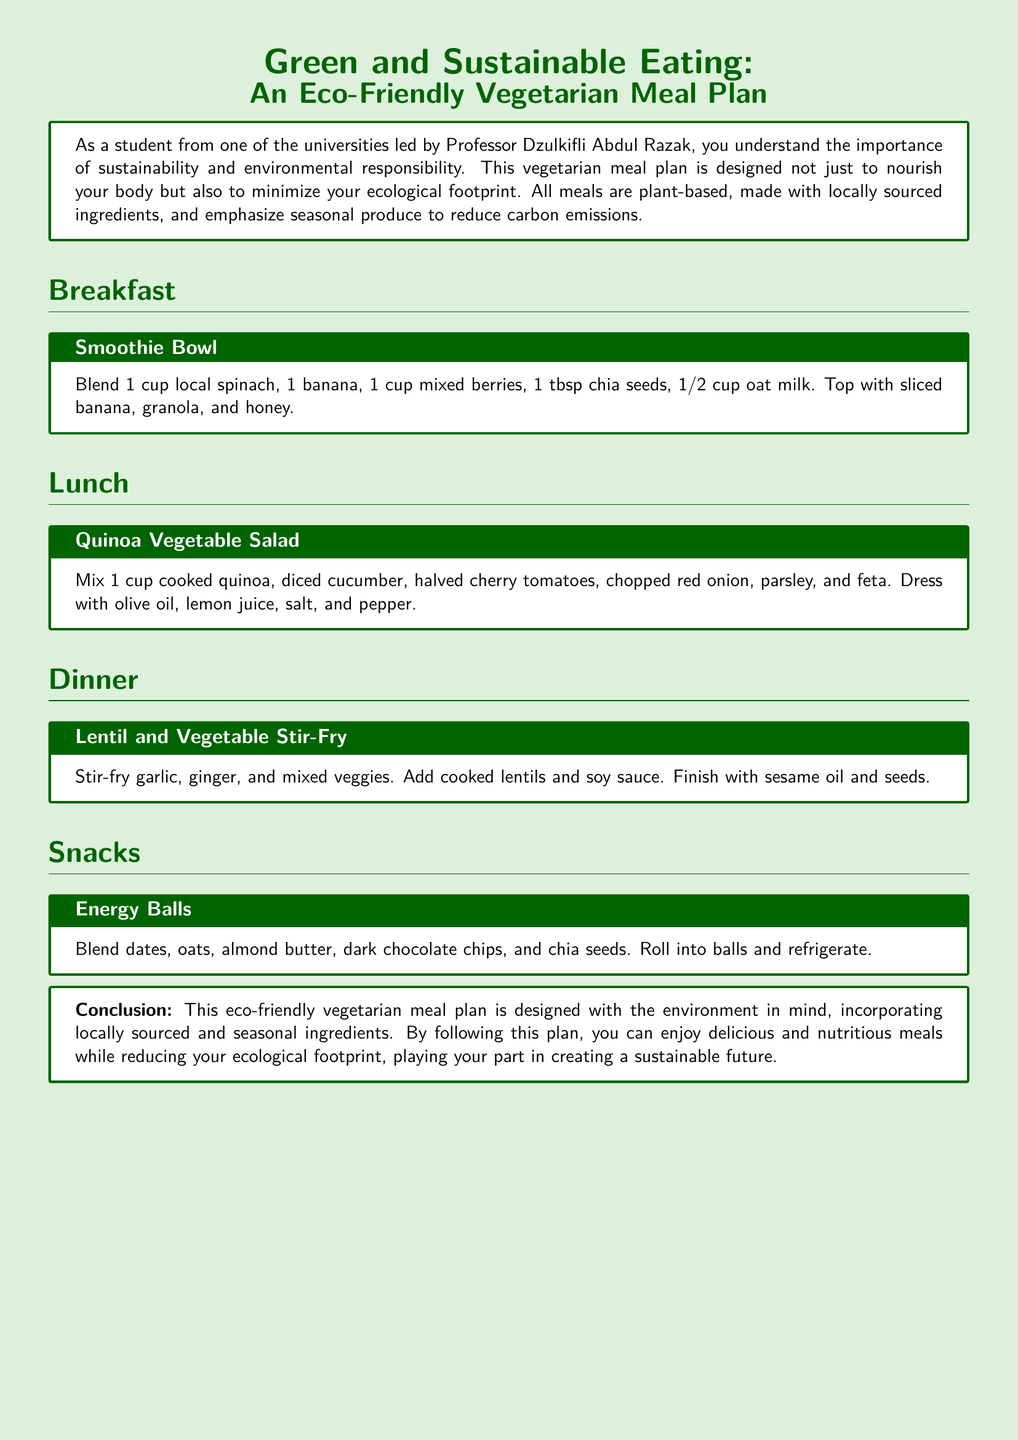What is the title of the meal plan? The title presents the main focus of the document, which emphasizes green and sustainable eating practices.
Answer: Green and Sustainable Eating: An Eco-Friendly Vegetarian Meal Plan Who is the target audience for the meal plan? The introduction specifies the intended audience who are environmentally conscious students connected to a specific university.
Answer: Environmentally conscious student How many sections are there in the meal plan? The document includes several distinct sections focusing on different meals throughout the day.
Answer: Four What key ingredient is in the smoothie bowl? The smoothie bowl recipe lists specific ingredients that contribute to its flavor and nutritional value.
Answer: Spinach What is used to dress the quinoa vegetable salad? The salad preparation mentions specific items used to enhance taste and freshness in the recipe.
Answer: Olive oil and lemon juice What type of meal is the energy balls classified as? The categorization of the food items will indicate its specific meal-related purpose within the day.
Answer: Snacks Which meal includes lentils? The dinner section specifically discusses a recipe that incorporates lentils as a primary protein source.
Answer: Lentil and Vegetable Stir-Fry What is the main focus of the meal plan? The conclusion summarizes the overall goal of the meal plan in terms of environmental sustainability and nutrition.
Answer: Reduce ecological footprint 